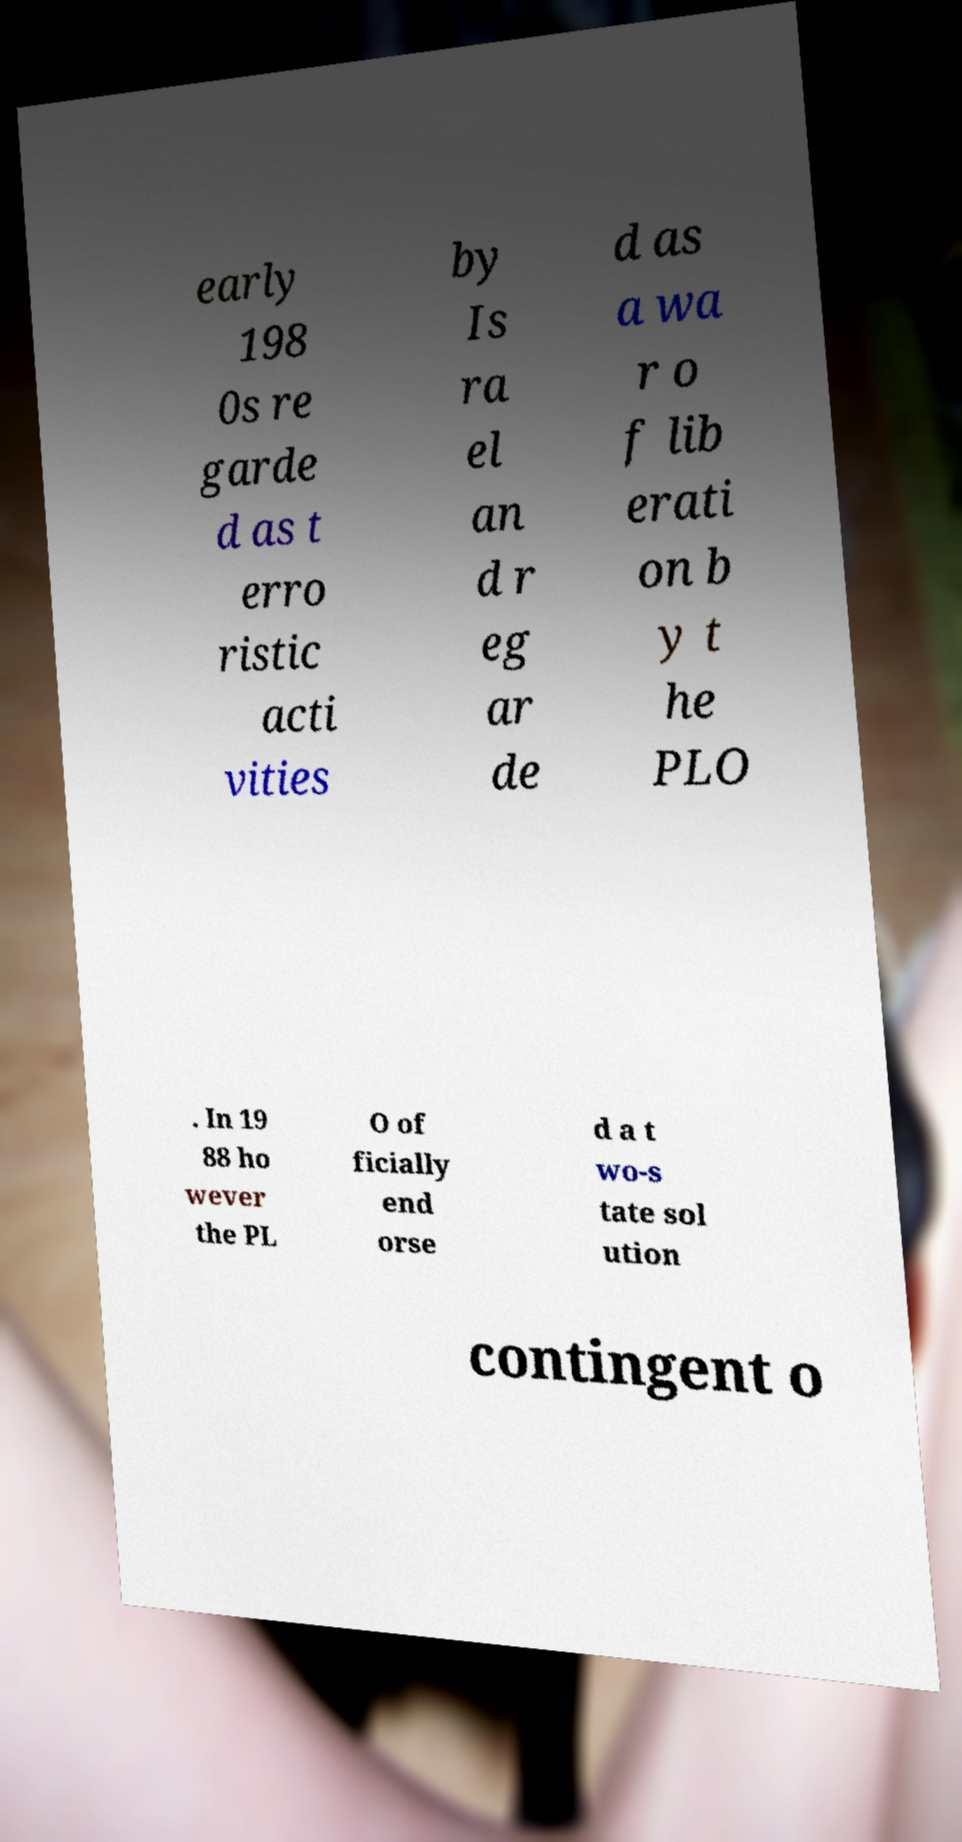I need the written content from this picture converted into text. Can you do that? early 198 0s re garde d as t erro ristic acti vities by Is ra el an d r eg ar de d as a wa r o f lib erati on b y t he PLO . In 19 88 ho wever the PL O of ficially end orse d a t wo-s tate sol ution contingent o 